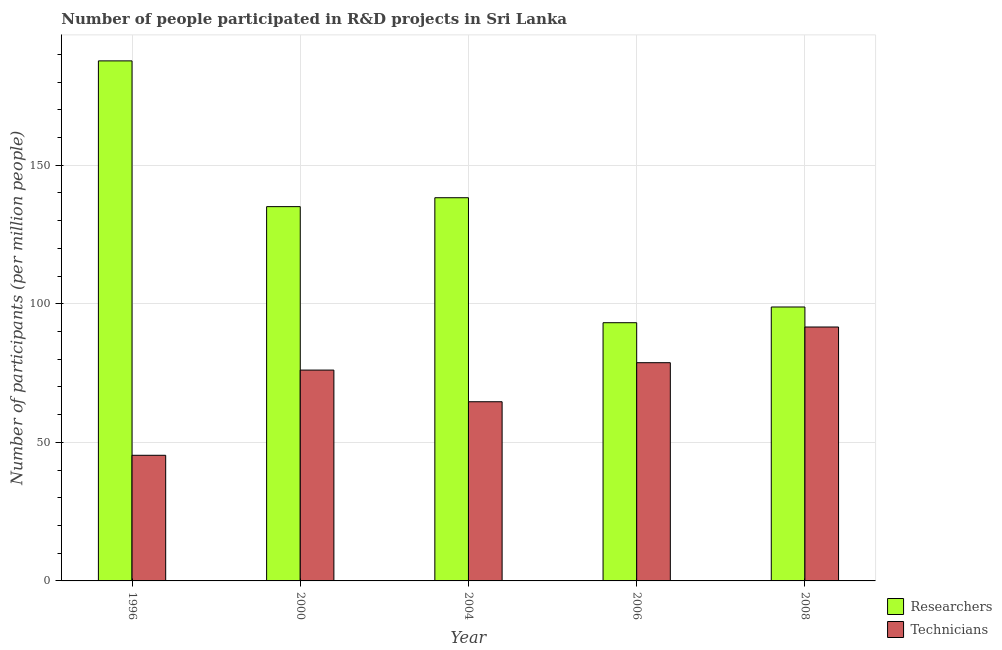Are the number of bars on each tick of the X-axis equal?
Provide a succinct answer. Yes. What is the label of the 3rd group of bars from the left?
Offer a terse response. 2004. What is the number of researchers in 2006?
Make the answer very short. 93.18. Across all years, what is the maximum number of technicians?
Offer a very short reply. 91.63. Across all years, what is the minimum number of technicians?
Your response must be concise. 45.34. What is the total number of researchers in the graph?
Offer a very short reply. 653.03. What is the difference between the number of researchers in 1996 and that in 2008?
Your answer should be compact. 88.81. What is the difference between the number of researchers in 2006 and the number of technicians in 2008?
Offer a terse response. -5.67. What is the average number of researchers per year?
Your answer should be very brief. 130.61. In the year 2006, what is the difference between the number of technicians and number of researchers?
Keep it short and to the point. 0. In how many years, is the number of researchers greater than 150?
Keep it short and to the point. 1. What is the ratio of the number of technicians in 1996 to that in 2008?
Provide a short and direct response. 0.49. Is the number of researchers in 1996 less than that in 2004?
Keep it short and to the point. No. Is the difference between the number of researchers in 1996 and 2006 greater than the difference between the number of technicians in 1996 and 2006?
Offer a terse response. No. What is the difference between the highest and the second highest number of technicians?
Your answer should be compact. 12.88. What is the difference between the highest and the lowest number of technicians?
Your response must be concise. 46.29. In how many years, is the number of researchers greater than the average number of researchers taken over all years?
Give a very brief answer. 3. Is the sum of the number of technicians in 2000 and 2006 greater than the maximum number of researchers across all years?
Provide a short and direct response. Yes. What does the 1st bar from the left in 2000 represents?
Keep it short and to the point. Researchers. What does the 1st bar from the right in 2008 represents?
Offer a very short reply. Technicians. How many bars are there?
Offer a terse response. 10. Are all the bars in the graph horizontal?
Make the answer very short. No. How many years are there in the graph?
Keep it short and to the point. 5. How many legend labels are there?
Provide a short and direct response. 2. How are the legend labels stacked?
Keep it short and to the point. Vertical. What is the title of the graph?
Make the answer very short. Number of people participated in R&D projects in Sri Lanka. What is the label or title of the Y-axis?
Make the answer very short. Number of participants (per million people). What is the Number of participants (per million people) of Researchers in 1996?
Keep it short and to the point. 187.66. What is the Number of participants (per million people) in Technicians in 1996?
Your answer should be very brief. 45.34. What is the Number of participants (per million people) in Researchers in 2000?
Offer a very short reply. 135.06. What is the Number of participants (per million people) in Technicians in 2000?
Offer a terse response. 76.08. What is the Number of participants (per million people) of Researchers in 2004?
Provide a succinct answer. 138.28. What is the Number of participants (per million people) of Technicians in 2004?
Make the answer very short. 64.66. What is the Number of participants (per million people) of Researchers in 2006?
Offer a terse response. 93.18. What is the Number of participants (per million people) of Technicians in 2006?
Offer a terse response. 78.75. What is the Number of participants (per million people) of Researchers in 2008?
Make the answer very short. 98.85. What is the Number of participants (per million people) of Technicians in 2008?
Offer a very short reply. 91.63. Across all years, what is the maximum Number of participants (per million people) in Researchers?
Give a very brief answer. 187.66. Across all years, what is the maximum Number of participants (per million people) in Technicians?
Offer a very short reply. 91.63. Across all years, what is the minimum Number of participants (per million people) of Researchers?
Your response must be concise. 93.18. Across all years, what is the minimum Number of participants (per million people) in Technicians?
Provide a succinct answer. 45.34. What is the total Number of participants (per million people) in Researchers in the graph?
Give a very brief answer. 653.03. What is the total Number of participants (per million people) of Technicians in the graph?
Give a very brief answer. 356.45. What is the difference between the Number of participants (per million people) of Researchers in 1996 and that in 2000?
Provide a short and direct response. 52.6. What is the difference between the Number of participants (per million people) of Technicians in 1996 and that in 2000?
Make the answer very short. -30.74. What is the difference between the Number of participants (per million people) of Researchers in 1996 and that in 2004?
Provide a short and direct response. 49.39. What is the difference between the Number of participants (per million people) in Technicians in 1996 and that in 2004?
Make the answer very short. -19.32. What is the difference between the Number of participants (per million people) of Researchers in 1996 and that in 2006?
Your response must be concise. 94.49. What is the difference between the Number of participants (per million people) in Technicians in 1996 and that in 2006?
Your response must be concise. -33.41. What is the difference between the Number of participants (per million people) in Researchers in 1996 and that in 2008?
Make the answer very short. 88.81. What is the difference between the Number of participants (per million people) in Technicians in 1996 and that in 2008?
Your answer should be compact. -46.29. What is the difference between the Number of participants (per million people) of Researchers in 2000 and that in 2004?
Your response must be concise. -3.21. What is the difference between the Number of participants (per million people) of Technicians in 2000 and that in 2004?
Give a very brief answer. 11.42. What is the difference between the Number of participants (per million people) of Researchers in 2000 and that in 2006?
Ensure brevity in your answer.  41.89. What is the difference between the Number of participants (per million people) in Technicians in 2000 and that in 2006?
Offer a terse response. -2.67. What is the difference between the Number of participants (per million people) of Researchers in 2000 and that in 2008?
Your response must be concise. 36.21. What is the difference between the Number of participants (per million people) of Technicians in 2000 and that in 2008?
Your answer should be compact. -15.55. What is the difference between the Number of participants (per million people) in Researchers in 2004 and that in 2006?
Make the answer very short. 45.1. What is the difference between the Number of participants (per million people) in Technicians in 2004 and that in 2006?
Provide a short and direct response. -14.09. What is the difference between the Number of participants (per million people) in Researchers in 2004 and that in 2008?
Give a very brief answer. 39.43. What is the difference between the Number of participants (per million people) of Technicians in 2004 and that in 2008?
Give a very brief answer. -26.97. What is the difference between the Number of participants (per million people) of Researchers in 2006 and that in 2008?
Give a very brief answer. -5.67. What is the difference between the Number of participants (per million people) in Technicians in 2006 and that in 2008?
Your answer should be compact. -12.88. What is the difference between the Number of participants (per million people) of Researchers in 1996 and the Number of participants (per million people) of Technicians in 2000?
Provide a short and direct response. 111.58. What is the difference between the Number of participants (per million people) in Researchers in 1996 and the Number of participants (per million people) in Technicians in 2004?
Your answer should be very brief. 123. What is the difference between the Number of participants (per million people) of Researchers in 1996 and the Number of participants (per million people) of Technicians in 2006?
Your response must be concise. 108.91. What is the difference between the Number of participants (per million people) in Researchers in 1996 and the Number of participants (per million people) in Technicians in 2008?
Provide a succinct answer. 96.03. What is the difference between the Number of participants (per million people) of Researchers in 2000 and the Number of participants (per million people) of Technicians in 2004?
Offer a very short reply. 70.4. What is the difference between the Number of participants (per million people) in Researchers in 2000 and the Number of participants (per million people) in Technicians in 2006?
Your response must be concise. 56.31. What is the difference between the Number of participants (per million people) of Researchers in 2000 and the Number of participants (per million people) of Technicians in 2008?
Ensure brevity in your answer.  43.44. What is the difference between the Number of participants (per million people) of Researchers in 2004 and the Number of participants (per million people) of Technicians in 2006?
Keep it short and to the point. 59.53. What is the difference between the Number of participants (per million people) in Researchers in 2004 and the Number of participants (per million people) in Technicians in 2008?
Ensure brevity in your answer.  46.65. What is the difference between the Number of participants (per million people) of Researchers in 2006 and the Number of participants (per million people) of Technicians in 2008?
Provide a succinct answer. 1.55. What is the average Number of participants (per million people) of Researchers per year?
Offer a terse response. 130.61. What is the average Number of participants (per million people) in Technicians per year?
Offer a very short reply. 71.29. In the year 1996, what is the difference between the Number of participants (per million people) of Researchers and Number of participants (per million people) of Technicians?
Your answer should be compact. 142.32. In the year 2000, what is the difference between the Number of participants (per million people) in Researchers and Number of participants (per million people) in Technicians?
Make the answer very short. 58.98. In the year 2004, what is the difference between the Number of participants (per million people) in Researchers and Number of participants (per million people) in Technicians?
Ensure brevity in your answer.  73.62. In the year 2006, what is the difference between the Number of participants (per million people) in Researchers and Number of participants (per million people) in Technicians?
Give a very brief answer. 14.43. In the year 2008, what is the difference between the Number of participants (per million people) of Researchers and Number of participants (per million people) of Technicians?
Make the answer very short. 7.22. What is the ratio of the Number of participants (per million people) in Researchers in 1996 to that in 2000?
Your answer should be very brief. 1.39. What is the ratio of the Number of participants (per million people) in Technicians in 1996 to that in 2000?
Your response must be concise. 0.6. What is the ratio of the Number of participants (per million people) in Researchers in 1996 to that in 2004?
Offer a terse response. 1.36. What is the ratio of the Number of participants (per million people) in Technicians in 1996 to that in 2004?
Offer a terse response. 0.7. What is the ratio of the Number of participants (per million people) in Researchers in 1996 to that in 2006?
Offer a terse response. 2.01. What is the ratio of the Number of participants (per million people) in Technicians in 1996 to that in 2006?
Provide a succinct answer. 0.58. What is the ratio of the Number of participants (per million people) of Researchers in 1996 to that in 2008?
Offer a very short reply. 1.9. What is the ratio of the Number of participants (per million people) of Technicians in 1996 to that in 2008?
Your response must be concise. 0.49. What is the ratio of the Number of participants (per million people) of Researchers in 2000 to that in 2004?
Offer a terse response. 0.98. What is the ratio of the Number of participants (per million people) of Technicians in 2000 to that in 2004?
Your answer should be compact. 1.18. What is the ratio of the Number of participants (per million people) in Researchers in 2000 to that in 2006?
Your answer should be very brief. 1.45. What is the ratio of the Number of participants (per million people) of Technicians in 2000 to that in 2006?
Keep it short and to the point. 0.97. What is the ratio of the Number of participants (per million people) in Researchers in 2000 to that in 2008?
Offer a very short reply. 1.37. What is the ratio of the Number of participants (per million people) of Technicians in 2000 to that in 2008?
Offer a very short reply. 0.83. What is the ratio of the Number of participants (per million people) of Researchers in 2004 to that in 2006?
Offer a terse response. 1.48. What is the ratio of the Number of participants (per million people) in Technicians in 2004 to that in 2006?
Keep it short and to the point. 0.82. What is the ratio of the Number of participants (per million people) of Researchers in 2004 to that in 2008?
Your response must be concise. 1.4. What is the ratio of the Number of participants (per million people) of Technicians in 2004 to that in 2008?
Provide a short and direct response. 0.71. What is the ratio of the Number of participants (per million people) in Researchers in 2006 to that in 2008?
Make the answer very short. 0.94. What is the ratio of the Number of participants (per million people) of Technicians in 2006 to that in 2008?
Ensure brevity in your answer.  0.86. What is the difference between the highest and the second highest Number of participants (per million people) in Researchers?
Provide a short and direct response. 49.39. What is the difference between the highest and the second highest Number of participants (per million people) in Technicians?
Offer a very short reply. 12.88. What is the difference between the highest and the lowest Number of participants (per million people) in Researchers?
Your answer should be very brief. 94.49. What is the difference between the highest and the lowest Number of participants (per million people) in Technicians?
Keep it short and to the point. 46.29. 